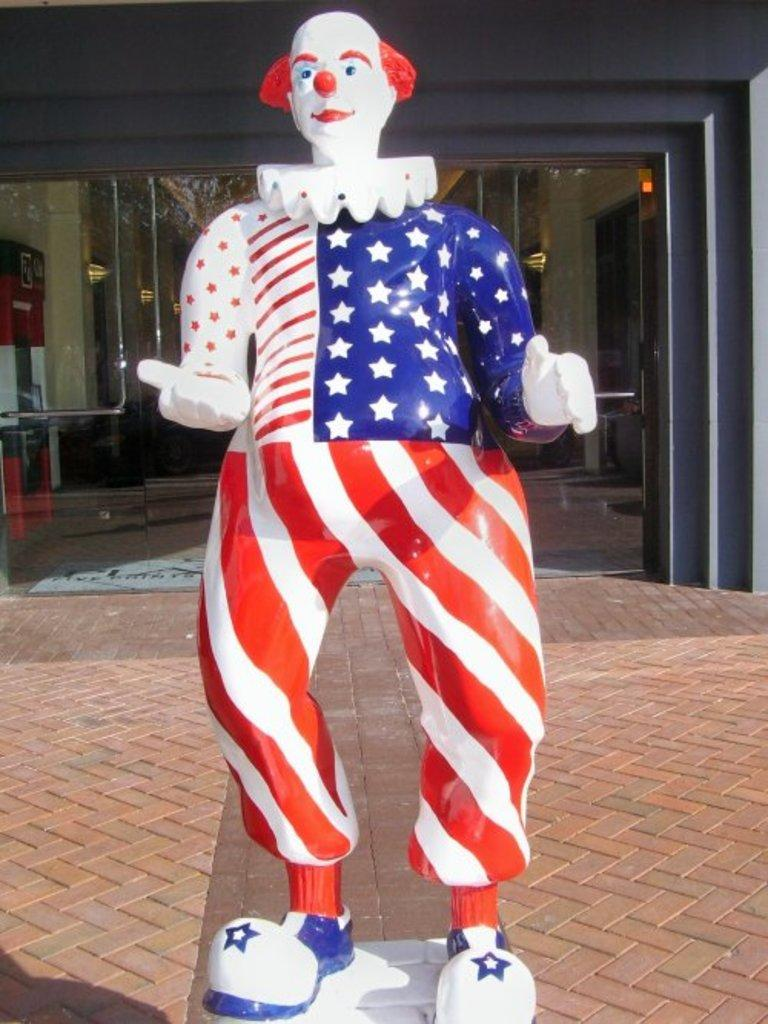What is the main subject of the image? There is a statue of a clown in the image. What can be seen beneath the statue? The ground is visible in the image. What is located behind the statue? There is a wall in the image. What material is present in the image that might be used for windows or displays? There is some glass in the image. What can be seen illuminating the area in the image? There are lights visible in the image. What object is located on the left side of the image? There is an object on the left side of the image. What type of boot is the clown wearing in the image? The image does not show the clown wearing any boots; it only depicts a statue of a clown. What is the clown's sense of humor like in the image? The image is a statue and does not convey a sense of humor. 